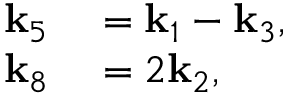Convert formula to latex. <formula><loc_0><loc_0><loc_500><loc_500>\begin{array} { r l } { k _ { 5 } } & = k _ { 1 } - k _ { 3 } , } \\ { k _ { 8 } } & = 2 k _ { 2 } , } \end{array}</formula> 